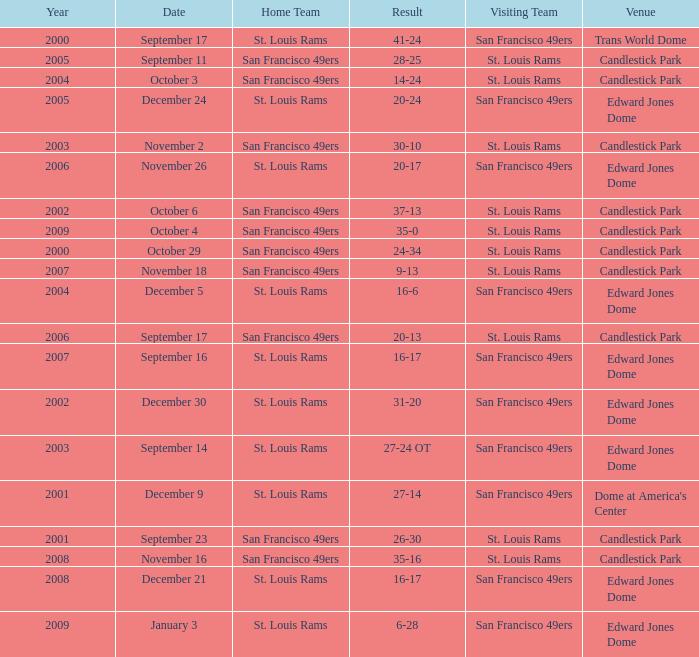What was the Venue of the San Francisco 49ers Home game with a Result of 30-10? Candlestick Park. 